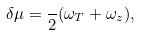<formula> <loc_0><loc_0><loc_500><loc_500>\delta \mu = \frac { } { 2 } ( \omega _ { T } + \omega _ { z } ) ,</formula> 